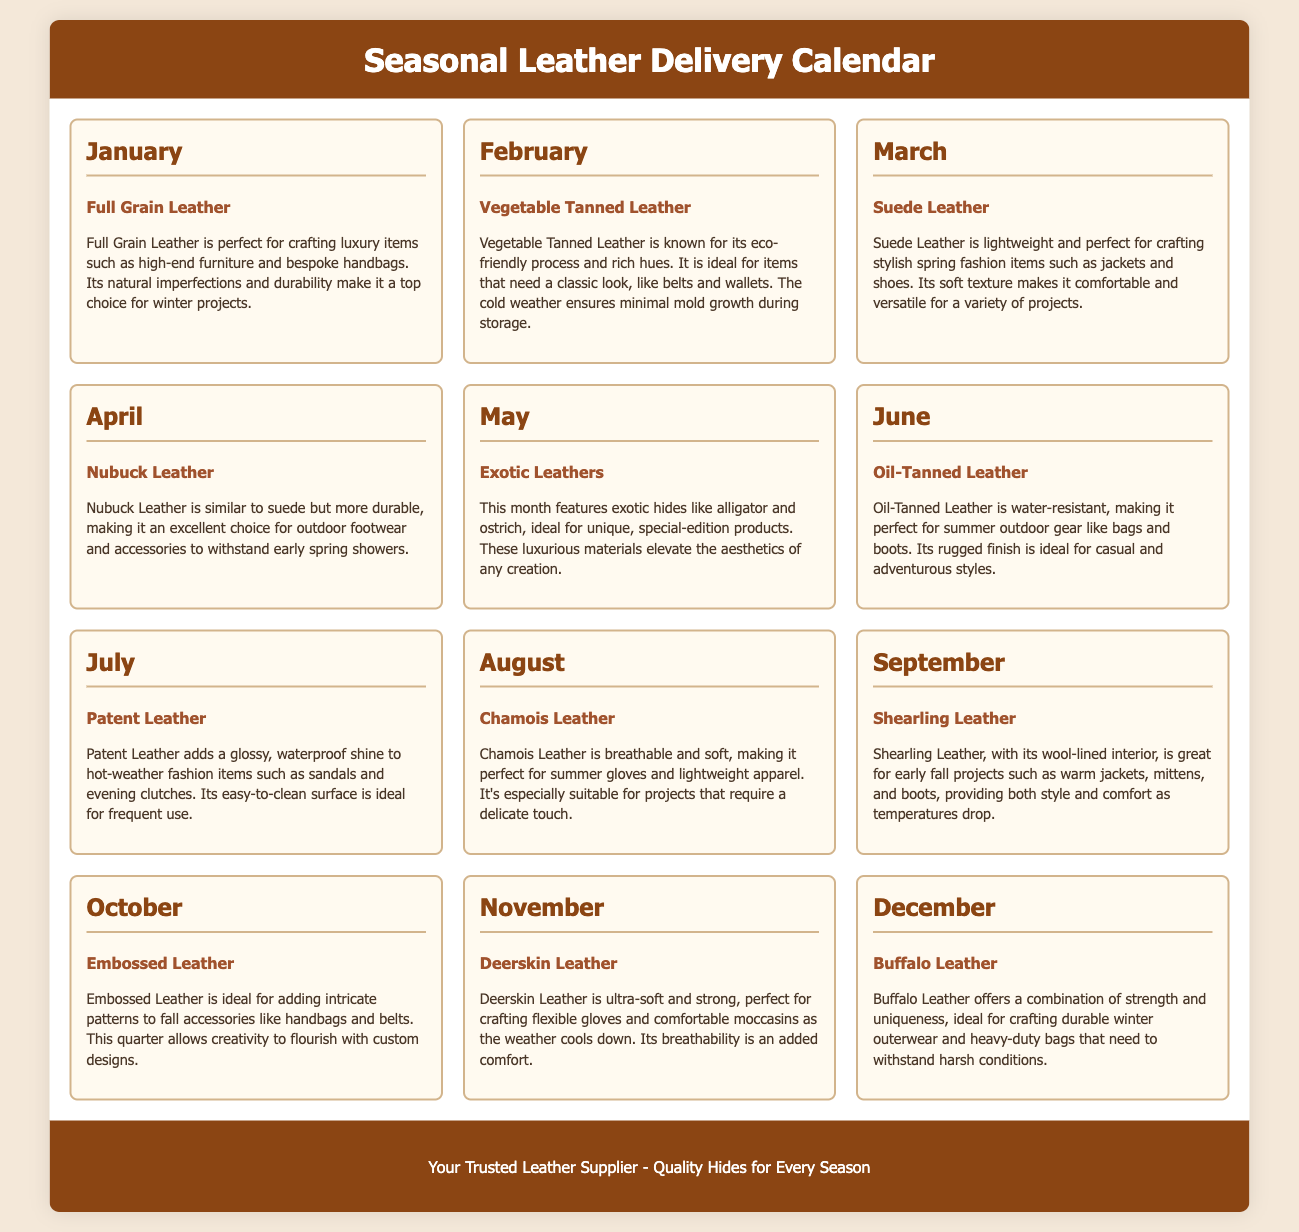What leather type is featured in January? The document specifies "Full Grain Leather" as the featured type for January.
Answer: Full Grain Leather Which leather is ideal for summer outdoor gear? June's section mentions "Oil-Tanned Leather" as perfect for summer outdoor gear due to its water-resistant properties.
Answer: Oil-Tanned Leather What is highlighted for February? The highlighted leather for February is detailed in the document as "Vegetable Tanned Leather."
Answer: Vegetable Tanned Leather Which month features exotic hides? May is identified for showcasing "Exotic Leathers" as a special highlight.
Answer: May What is the primary quality of Deerskin Leather listed for November? The document states that Deerskin Leather is described as "ultra-soft and strong."
Answer: ultra-soft and strong What type of leather is perfect for fall accessories in October? The document specifies "Embossed Leather" as ideal for fall accessories.
Answer: Embossed Leather Which leather type is noted for its glossy shine in July? The leather type for July that is described as having a glossy shine is "Patent Leather."
Answer: Patent Leather What is the main use for Nubuck Leather mentioned in April? Nubuck Leather is noted for being an excellent choice for "outdoor footwear and accessories."
Answer: outdoor footwear and accessories What does Shearling Leather provide in September? Shearling Leather is mentioned as providing "style and comfort" for early fall projects.
Answer: style and comfort 